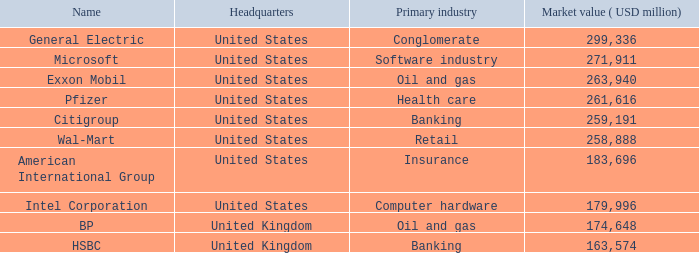How many ranks have an industry of health care? 1.0. 